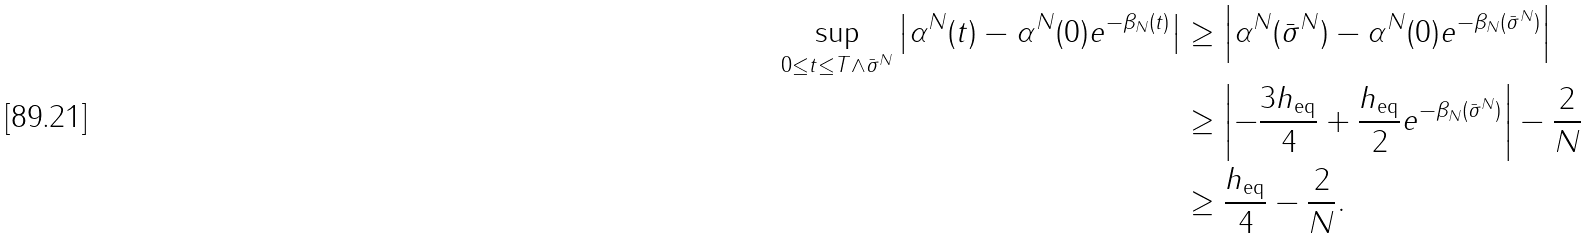<formula> <loc_0><loc_0><loc_500><loc_500>\sup _ { 0 \leq t \leq T \wedge \bar { \sigma } ^ { N } } \left | \alpha ^ { N } ( t ) - \alpha ^ { N } ( 0 ) e ^ { - \beta _ { N } ( t ) } \right | & \geq \left | \alpha ^ { N } ( \bar { \sigma } ^ { N } ) - \alpha ^ { N } ( 0 ) e ^ { - \beta _ { N } ( \bar { \sigma } ^ { N } ) } \right | \\ & \geq \left | - \frac { 3 h _ { \text {eq} } } { 4 } + \frac { h _ { \text {eq} } } { 2 } e ^ { - \beta _ { N } ( \bar { \sigma } ^ { N } ) } \right | - \frac { 2 } { N } \\ & \geq \frac { h _ { \text {eq} } } { 4 } - \frac { 2 } { N } .</formula> 